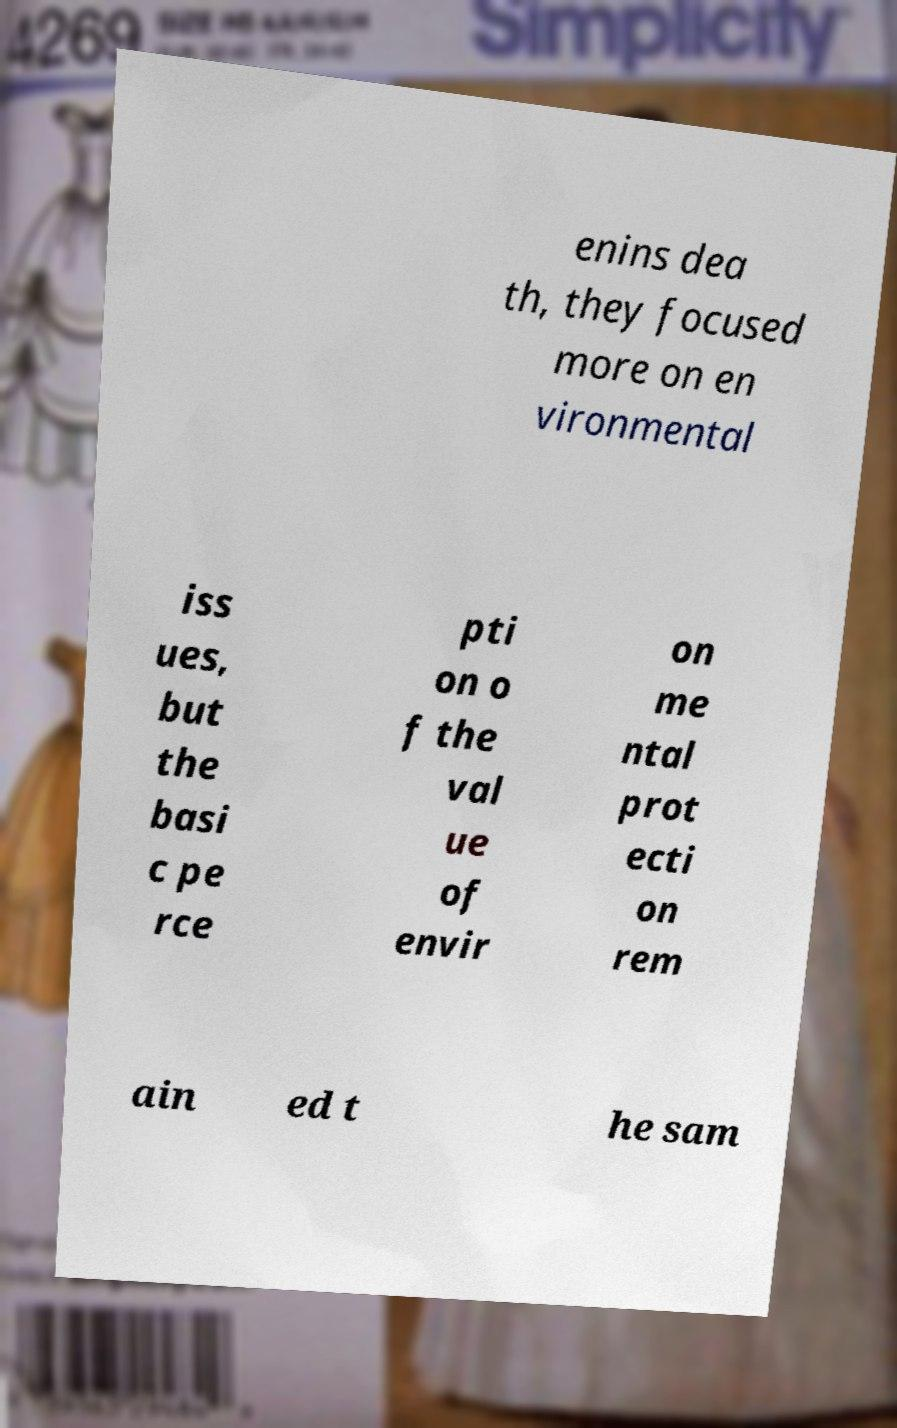I need the written content from this picture converted into text. Can you do that? enins dea th, they focused more on en vironmental iss ues, but the basi c pe rce pti on o f the val ue of envir on me ntal prot ecti on rem ain ed t he sam 